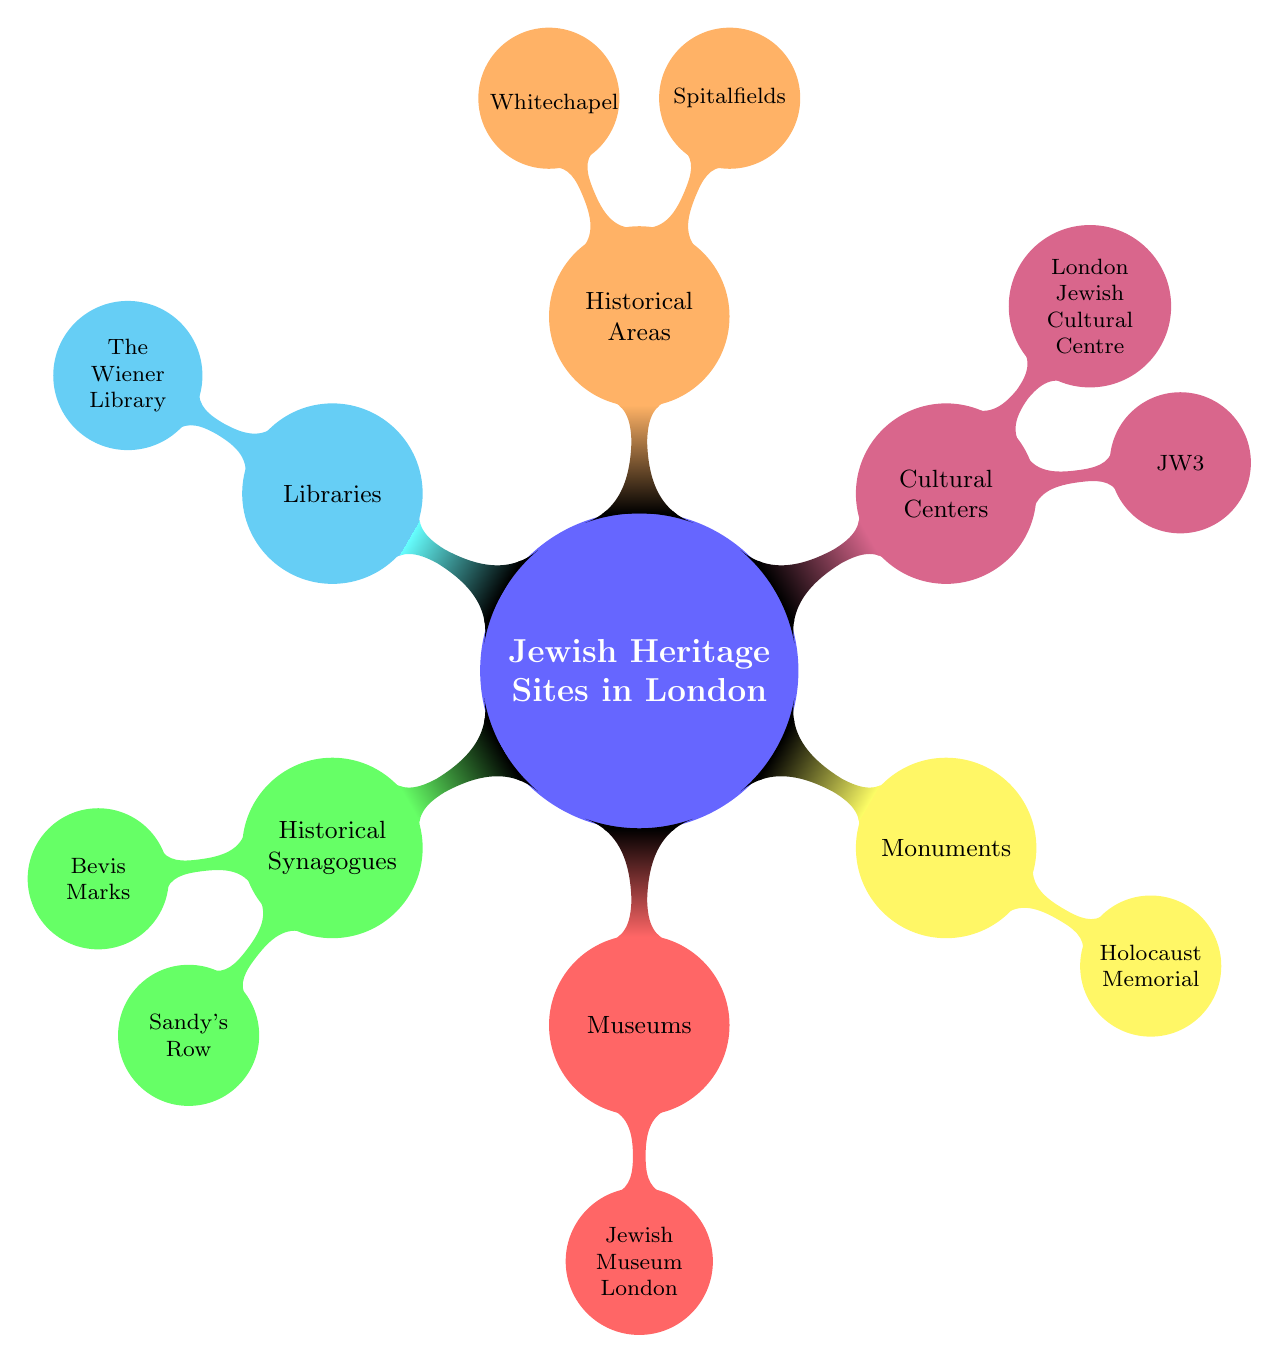What are the two main categories represented in the diagram? The main categories depicted in the mind map include 'Historical Synagogues' and 'Museums'. Both of these categories represent key types of Jewish heritage sites in London.
Answer: Historical Synagogues and Museums How many cultural centers are listed? The diagram shows two cultural centers: JW3 and the London Jewish Cultural Centre. Counting these provides the total number of cultural centers.
Answer: 2 Which synagogue is the oldest in the UK? Referring to the node under 'Historical Synagogues', Bevis Marks Synagogue is identified as the oldest synagogue in the UK.
Answer: Bevis Marks Synagogue What type of site is the Holocaust Memorial in Hyde Park? The node 'Holocaust Memorial in Hyde Park' falls under the 'Monuments' category, indicating that it is categorized as a monument related to Jewish heritage.
Answer: Monument Which area is known as the heart of the Jewish immigrant community? The diagram identifies Spitalfields under the 'Historical Areas' category, noting that it once served as the heart of the Jewish immigrant community.
Answer: Spitalfields How are the libraries categorized within the mind map? The diagram includes 'Libraries' as a separate category, indicating that this type encompasses specific sites, emphasizing their relevance to Jewish heritage.
Answer: Libraries Which historical area is associated with vibrant culture? The mind map indicates that Whitechapel is known for its vibrant culture, signifying its historical importance within the Jewish community.
Answer: Whitechapel What visual structure is used in this mind map? The diagram is arranged in a radial structure, where the central node (Jewish Heritage Sites in London) branches out into several categories and subcategories, typical of a mind map format.
Answer: Radial structure How many historical synagogues are mentioned? The mind map lists two historical synagogues: Bevis Marks and Sandy's Row, which can be counted under the 'Historical Synagogues' category.
Answer: 2 